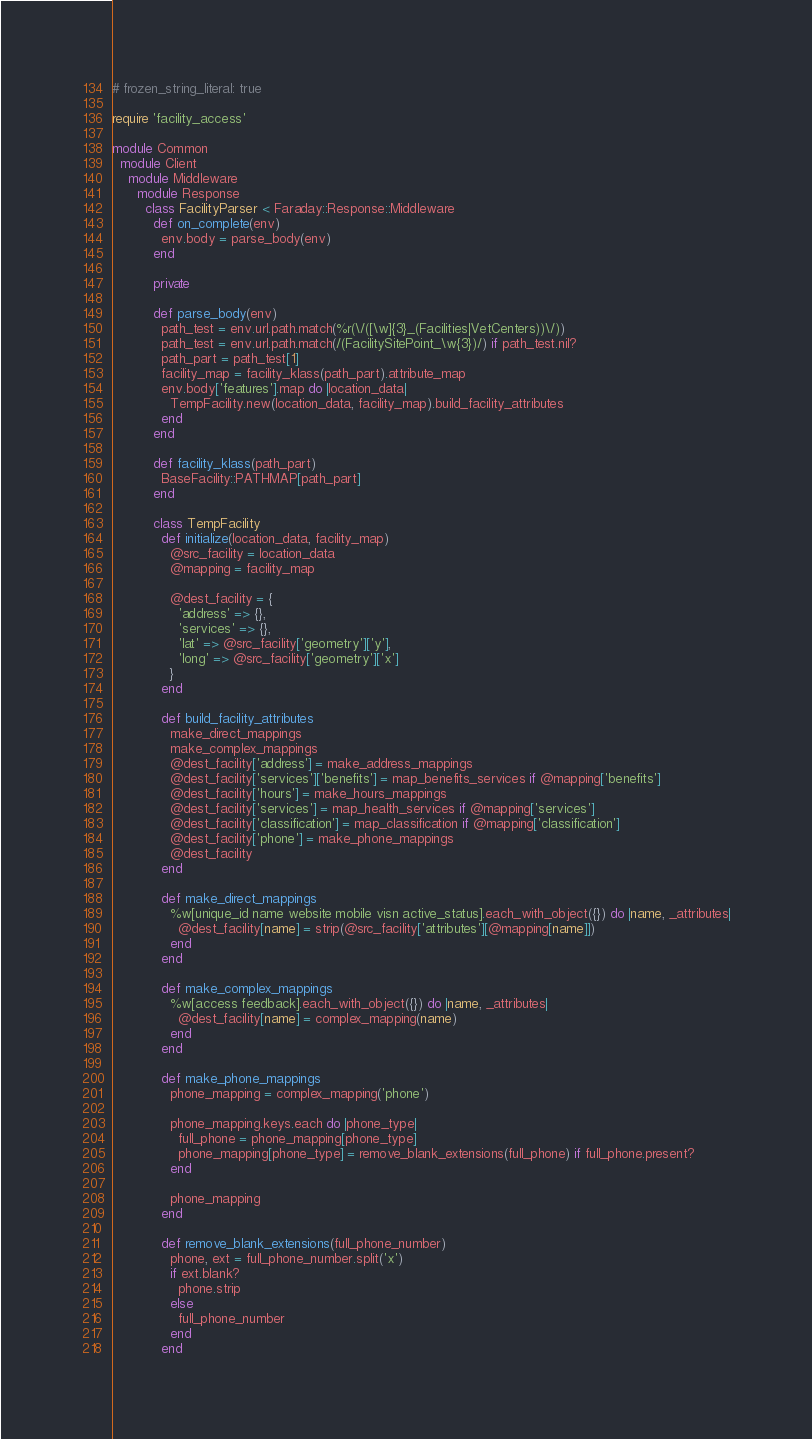Convert code to text. <code><loc_0><loc_0><loc_500><loc_500><_Ruby_># frozen_string_literal: true

require 'facility_access'

module Common
  module Client
    module Middleware
      module Response
        class FacilityParser < Faraday::Response::Middleware
          def on_complete(env)
            env.body = parse_body(env)
          end

          private

          def parse_body(env)
            path_test = env.url.path.match(%r(\/([\w]{3}_(Facilities|VetCenters))\/))
            path_test = env.url.path.match(/(FacilitySitePoint_\w{3})/) if path_test.nil?
            path_part = path_test[1]
            facility_map = facility_klass(path_part).attribute_map
            env.body['features'].map do |location_data|
              TempFacility.new(location_data, facility_map).build_facility_attributes
            end
          end

          def facility_klass(path_part)
            BaseFacility::PATHMAP[path_part]
          end

          class TempFacility
            def initialize(location_data, facility_map)
              @src_facility = location_data
              @mapping = facility_map

              @dest_facility = {
                'address' => {},
                'services' => {},
                'lat' => @src_facility['geometry']['y'],
                'long' => @src_facility['geometry']['x']
              }
            end

            def build_facility_attributes
              make_direct_mappings
              make_complex_mappings
              @dest_facility['address'] = make_address_mappings
              @dest_facility['services']['benefits'] = map_benefits_services if @mapping['benefits']
              @dest_facility['hours'] = make_hours_mappings
              @dest_facility['services'] = map_health_services if @mapping['services']
              @dest_facility['classification'] = map_classification if @mapping['classification']
              @dest_facility['phone'] = make_phone_mappings
              @dest_facility
            end

            def make_direct_mappings
              %w[unique_id name website mobile visn active_status].each_with_object({}) do |name, _attributes|
                @dest_facility[name] = strip(@src_facility['attributes'][@mapping[name]])
              end
            end

            def make_complex_mappings
              %w[access feedback].each_with_object({}) do |name, _attributes|
                @dest_facility[name] = complex_mapping(name)
              end
            end

            def make_phone_mappings
              phone_mapping = complex_mapping('phone')

              phone_mapping.keys.each do |phone_type|
                full_phone = phone_mapping[phone_type]
                phone_mapping[phone_type] = remove_blank_extensions(full_phone) if full_phone.present?
              end

              phone_mapping
            end

            def remove_blank_extensions(full_phone_number)
              phone, ext = full_phone_number.split('x')
              if ext.blank?
                phone.strip
              else
                full_phone_number
              end
            end
</code> 